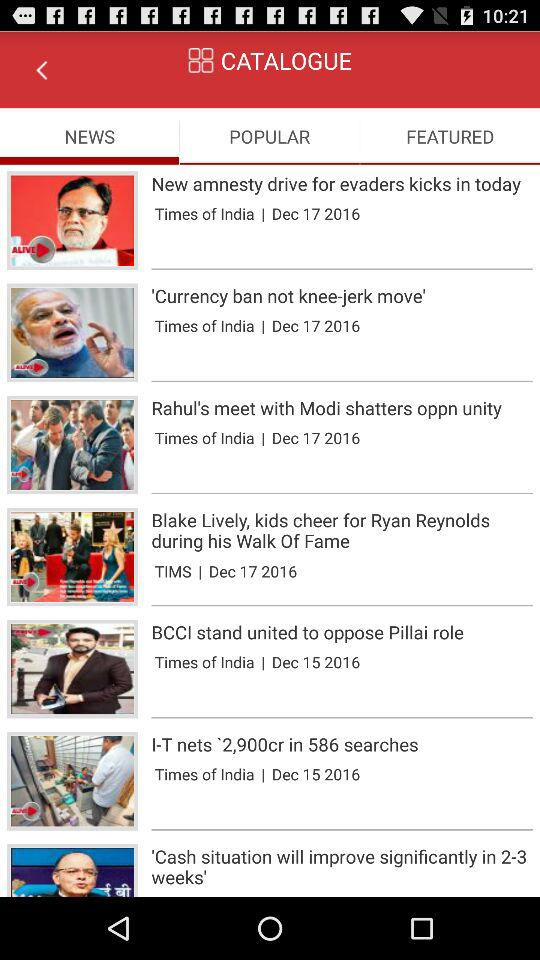What is the posted date of the news "'Currency ban not knee-jerk move'"? The posted date of the news is December 17, 2016. 